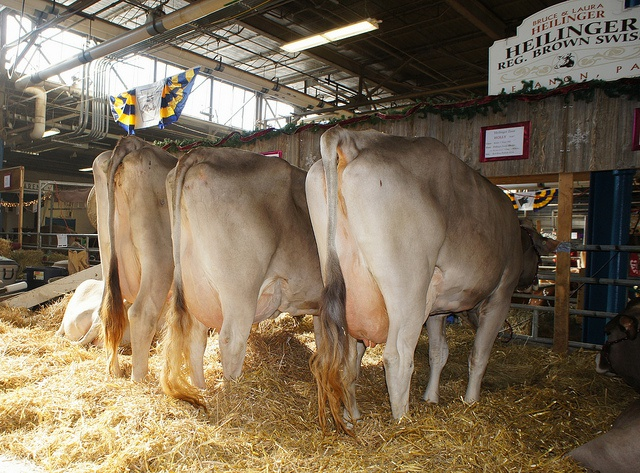Describe the objects in this image and their specific colors. I can see cow in gray, darkgray, maroon, and black tones, cow in gray and tan tones, cow in gray and tan tones, cow in gray, ivory, and tan tones, and cow in gray and black tones in this image. 